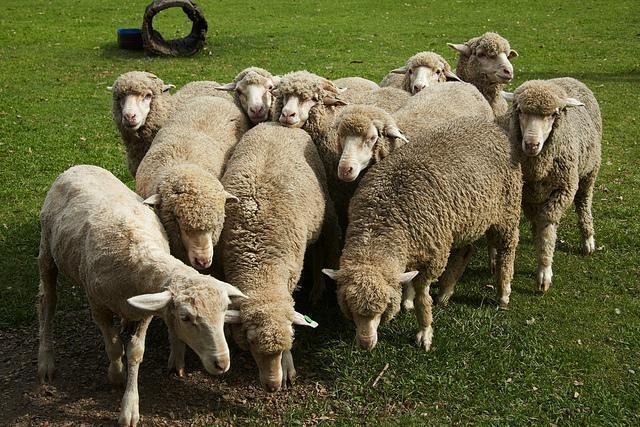How many animals are in the pic?
Give a very brief answer. 11. How many sheep are visible?
Give a very brief answer. 9. 